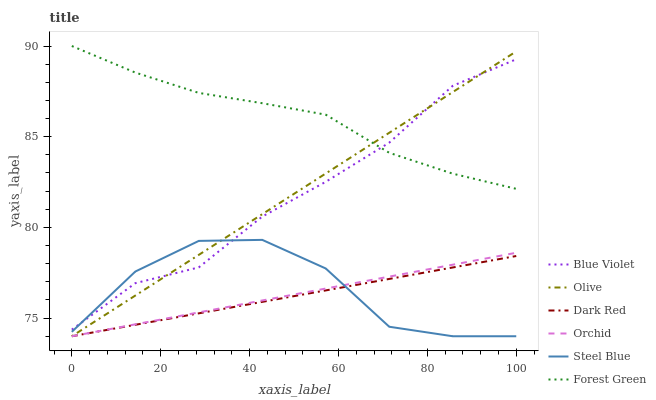Does Steel Blue have the minimum area under the curve?
Answer yes or no. No. Does Steel Blue have the maximum area under the curve?
Answer yes or no. No. Is Forest Green the smoothest?
Answer yes or no. No. Is Forest Green the roughest?
Answer yes or no. No. Does Forest Green have the lowest value?
Answer yes or no. No. Does Steel Blue have the highest value?
Answer yes or no. No. Is Orchid less than Forest Green?
Answer yes or no. Yes. Is Forest Green greater than Steel Blue?
Answer yes or no. Yes. Does Orchid intersect Forest Green?
Answer yes or no. No. 